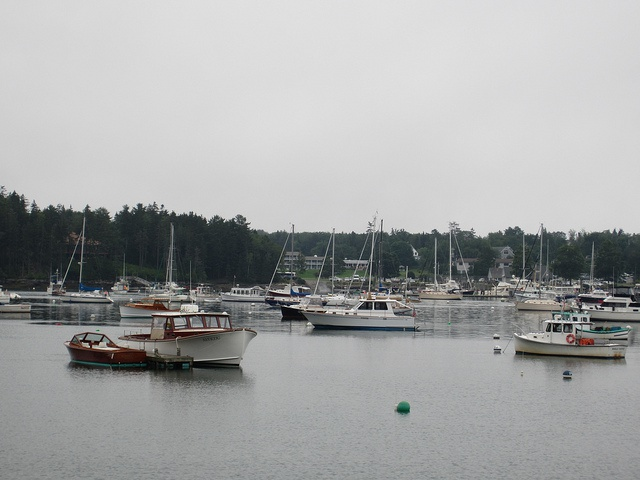Describe the objects in this image and their specific colors. I can see boat in lightgray, gray, black, darkgray, and maroon tones, boat in lightgray, darkgray, gray, and black tones, boat in lightgray, black, gray, darkgray, and purple tones, boat in lightgray, gray, darkgray, and black tones, and boat in lightgray, gray, darkgray, black, and maroon tones in this image. 